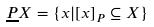Convert formula to latex. <formula><loc_0><loc_0><loc_500><loc_500>\underline { P } X = \{ x | [ x ] _ { P } \subseteq X \}</formula> 